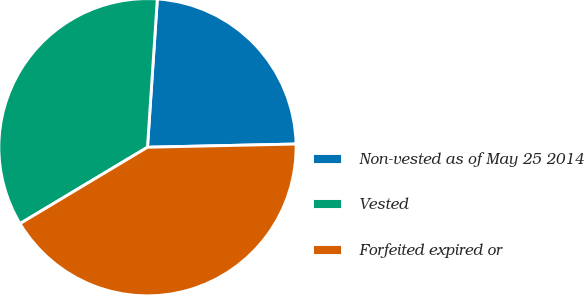Convert chart. <chart><loc_0><loc_0><loc_500><loc_500><pie_chart><fcel>Non-vested as of May 25 2014<fcel>Vested<fcel>Forfeited expired or<nl><fcel>23.6%<fcel>34.65%<fcel>41.75%<nl></chart> 